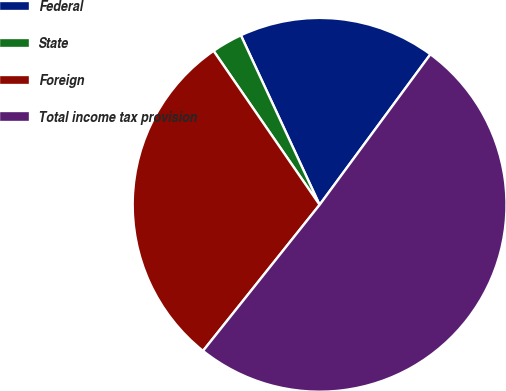Convert chart to OTSL. <chart><loc_0><loc_0><loc_500><loc_500><pie_chart><fcel>Federal<fcel>State<fcel>Foreign<fcel>Total income tax provision<nl><fcel>17.02%<fcel>2.68%<fcel>29.68%<fcel>50.62%<nl></chart> 